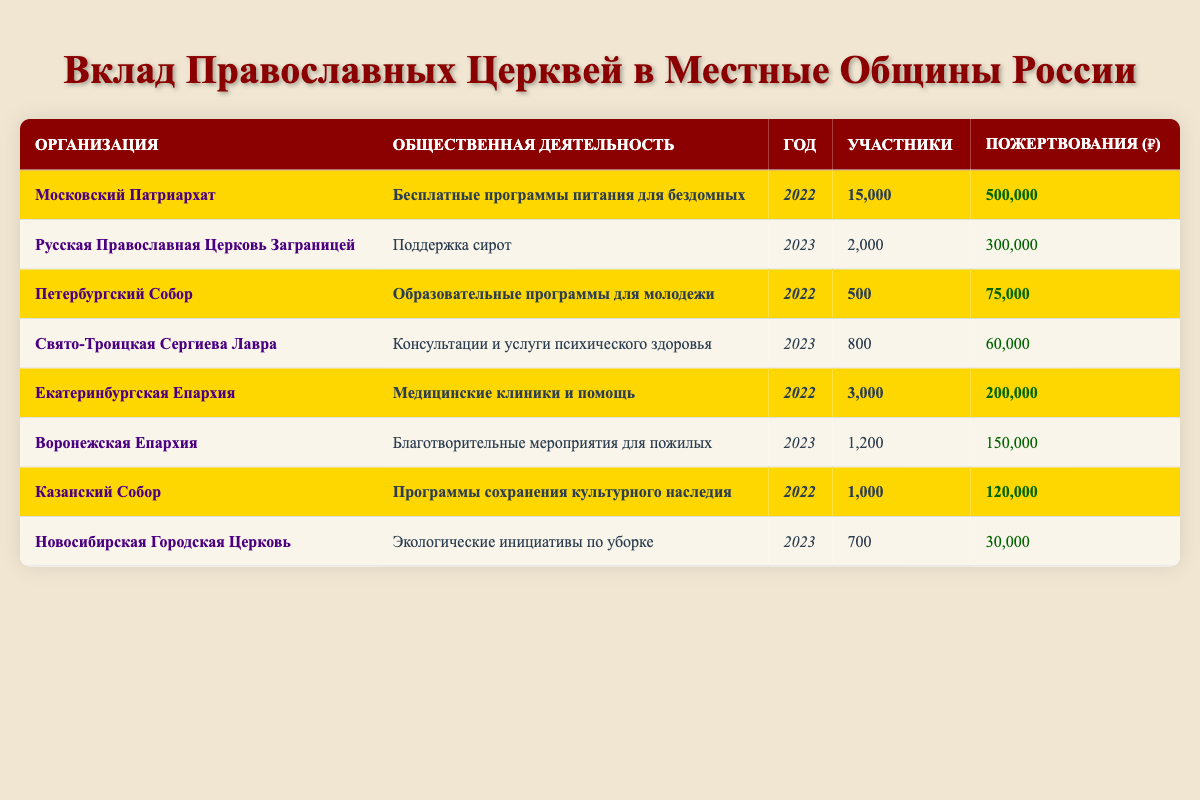What community service did the Moscow Patriarchate provide in 2022? The table indicates that the Moscow Patriarchate provided free meal programs for the homeless in 2022.
Answer: Free meal programs for the homeless How many participants were involved in the Ekaterinburg Diocese's community service in 2022? The table shows that the Ekaterinburg Diocese had 3,000 participants in their health clinics and medical assistance in 2022.
Answer: 3,000 What is the total amount of donations made by the highlighted organizations in 2022? To find this, sum the donations of the highlighted organizations for 2022: 500,000 (Moscow Patriarchate) + 75,000 (St. Petersburg Cathedral) + 200,000 (Ekaterinburg Diocese) + 120,000 (Kazan Cathedral) equals 895,000.
Answer: 895,000 Were there more participants in the community service by the Moscow Patriarchate or the Ekaterinburg Diocese in 2022? According to the table, the Moscow Patriarchate had 15,000 participants, while the Ekaterinburg Diocese had 3,000 participants. Therefore, the Moscow Patriarchate had more participants.
Answer: Yes, the Moscow Patriarchate had more Which highlighted organization had the least number of participants in 2022? The highlighted organizations for 2022 were the Moscow Patriarchate (15,000), St. Petersburg Cathedral (500), Ekaterinburg Diocese (3,000), and Kazan Cathedral (1,000). Among these, the St. Petersburg Cathedral had the least with 500 participants.
Answer: St. Petersburg Cathedral How many more participants did the Moscow Patriarchate have compared to the St. Petersburg Cathedral in 2022? The Moscow Patriarchate had 15,000 participants, while the St. Petersburg Cathedral had 500. The difference is 15,000 - 500 = 14,500 participants.
Answer: 14,500 Is the total amount of donations made by the Voronezh Eparchy greater than the donations made by the St. Petersburg Cathedral? The table shows the Voronezh Eparchy had 150,000 in donations, while the St. Petersburg Cathedral had 75,000. Since 150,000 is greater than 75,000, the statement is true.
Answer: Yes, it is greater What was the average number of participants for all highlighted organizations in 2022? The highlighted organizations in 2022 are the Moscow Patriarchate (15,000), St. Petersburg Cathedral (500), Ekaterinburg Diocese (3,000), and Kazan Cathedral (1,000). The total participants is 15,000 + 500 + 3,000 + 1,000 = 19,500. The average is 19,500 / 4 = 4,875.
Answer: 4,875 If we combine the donations from both highlighted organizations in 2022, do we get a total greater than 800,000? The highlighted organizations’ donations are 500,000 (Moscow Patriarchate), 75,000 (St. Petersburg Cathedral), 200,000 (Ekaterinburg Diocese), and 120,000 (Kazan Cathedral). The total is 500,000 + 75,000 + 200,000 + 120,000 = 895,000, which is indeed greater than 800,000.
Answer: Yes, it is greater 